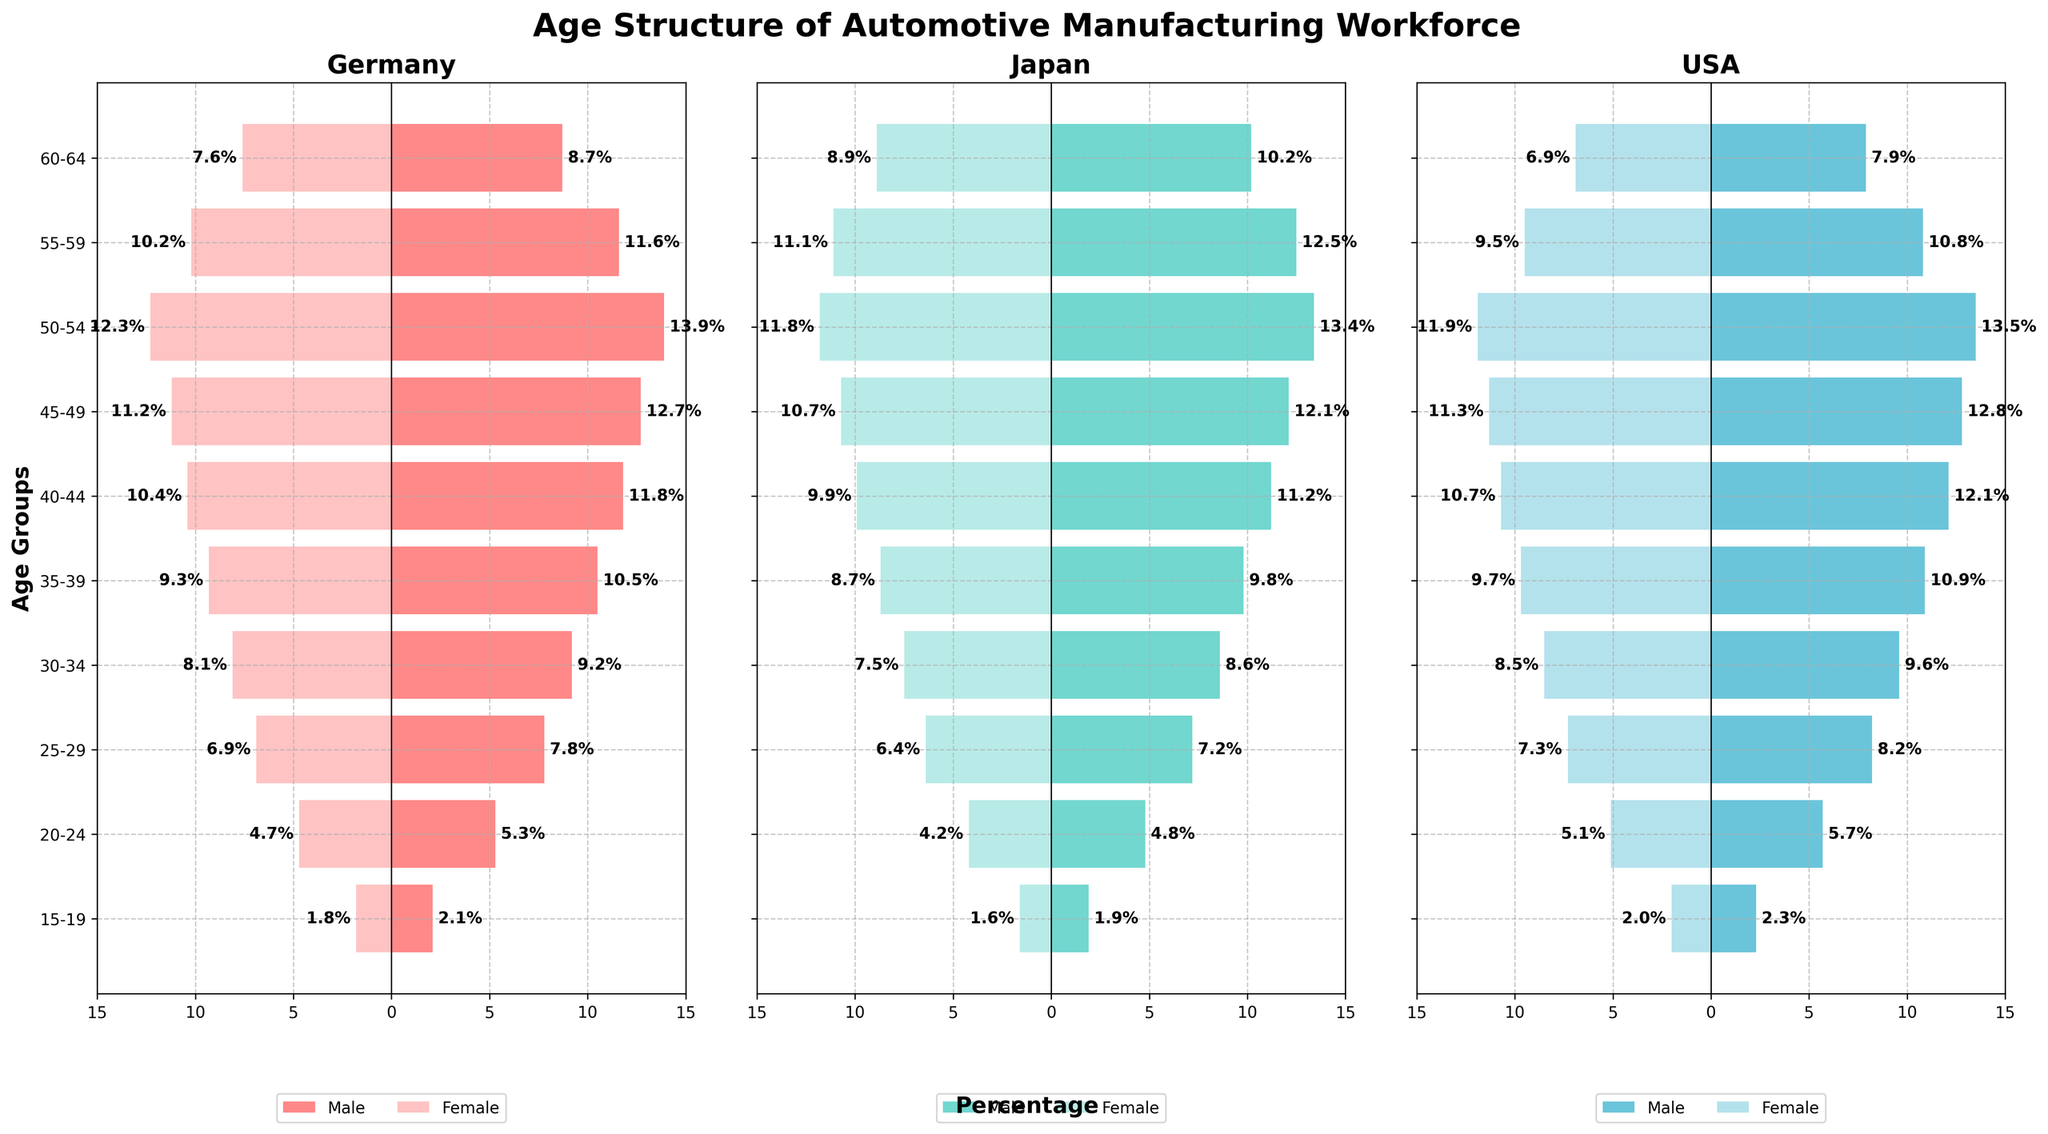What is the title of the figure? The title of the figure is displayed at the top-center of the plot in bold. It is "Age Structure of Automotive Manufacturing Workforce".
Answer: Age Structure of Automotive Manufacturing Workforce Which country has the largest percentage of male workers in the 45-49 age group? Look at the bar lengths for the 45-49 age group in each country's section. The USA has the largest percentage at 12.8%.
Answer: USA Which age group has the smallest percentage of female workers in Germany? Examine the bar lengths for female workers across all age groups in Germany. The 15-19 age group has the smallest percentage at 1.8%.
Answer: 15-19 Compare the percentage of male workers aged 50-54 and 55-59 in Japan. Which age group is larger? Look at the bar lengths in Japan's section for the 50-54 and 55-59 age groups. The percentage of male workers aged 50-54 (13.4%) is larger than those aged 55-59 (12.5%).
Answer: 50-54 What is the difference in the percentage of female workers aged 25-29 and 30-34 in the USA? Calculate the percentage difference between the female workers aged 25-29 (7.3%) and 30-34 (8.5%). The difference is 8.5% - 7.3% = 1.2%.
Answer: 1.2% How does the percentage of female workers aged 60-64 compare between Germany and Japan? Compare the lengths of the bars for the age group 60-64 in both countries. In Germany, it's 7.6%, and in Japan, it's 8.9%. Japan has a higher percentage.
Answer: Japan Which age group in Germany has the highest percentage of female workers? Check all the age groups in Germany for the female worker bars. The 50-54 age group has the highest percentage at 12.3%.
Answer: 50-54 Is the percentage of male workers in the USA consistently higher in older age groups (55-59 and 60-64) than in Japan? Compare the lengths of the bars for male workers in the USA and Japan for the age groups 55-59 and 60-64. In the USA, it's 10.8% and 7.9%, while in Japan, it's 12.5% and 10.2%. Japan has higher percentages, so the USA is not consistently higher.
Answer: No Which age group has the most similar percentages of male and female workers in Germany? Look for age groups in Germany where the male and female bars are closest in length. The age group 15-19 has close percentages with males at 2.1% and females at 1.8%, making a small difference of 0.3%.
Answer: 15-19 